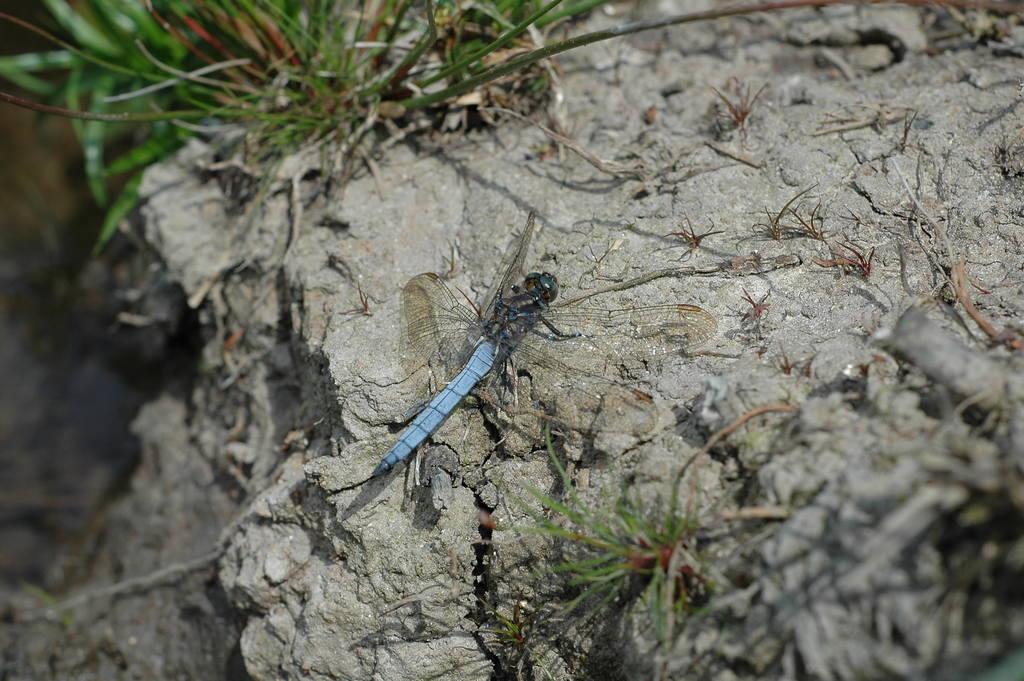How would you summarize this image in a sentence or two? In this image I can see an insect which is blue, black and green in color and some grass which is green in color on the ground. 